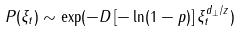<formula> <loc_0><loc_0><loc_500><loc_500>P ( \xi _ { t } ) \sim \exp ( - D \, [ - \ln ( 1 - p ) ] \, \xi _ { t } ^ { d _ { \bot } / z } )</formula> 